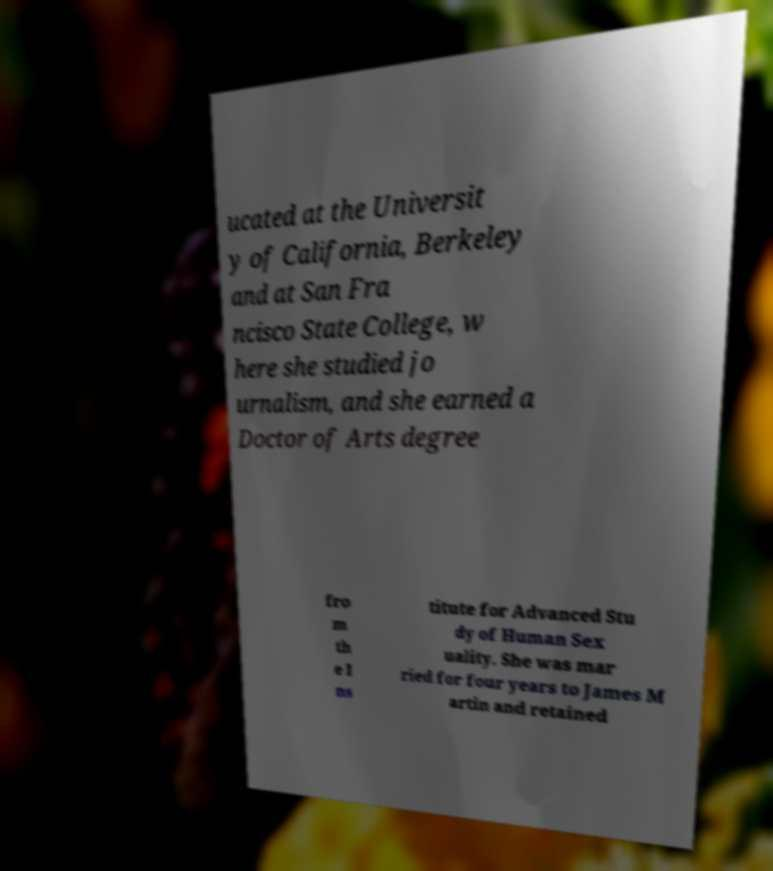For documentation purposes, I need the text within this image transcribed. Could you provide that? ucated at the Universit y of California, Berkeley and at San Fra ncisco State College, w here she studied jo urnalism, and she earned a Doctor of Arts degree fro m th e I ns titute for Advanced Stu dy of Human Sex uality. She was mar ried for four years to James M artin and retained 